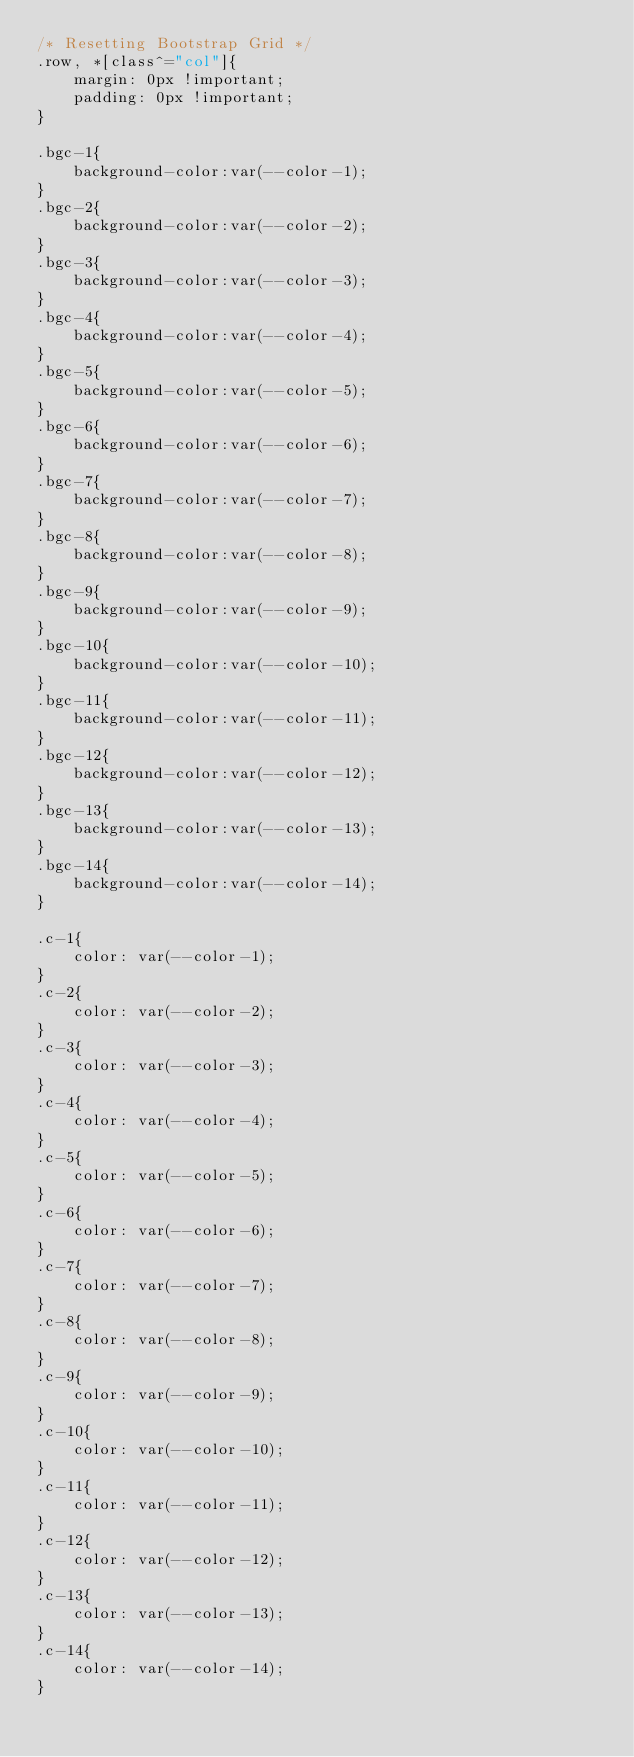<code> <loc_0><loc_0><loc_500><loc_500><_CSS_>/* Resetting Bootstrap Grid */
.row, *[class^="col"]{
    margin: 0px !important;
    padding: 0px !important;
}

.bgc-1{
    background-color:var(--color-1);
}
.bgc-2{
    background-color:var(--color-2);
}
.bgc-3{
    background-color:var(--color-3);
}
.bgc-4{
    background-color:var(--color-4);
}
.bgc-5{
    background-color:var(--color-5);
}
.bgc-6{
    background-color:var(--color-6);
}
.bgc-7{
    background-color:var(--color-7);
}
.bgc-8{
    background-color:var(--color-8);
}
.bgc-9{
    background-color:var(--color-9);
}
.bgc-10{
    background-color:var(--color-10);
}
.bgc-11{
    background-color:var(--color-11);
}
.bgc-12{
    background-color:var(--color-12);
}
.bgc-13{
    background-color:var(--color-13);
}
.bgc-14{
    background-color:var(--color-14);
}

.c-1{
    color: var(--color-1);
}
.c-2{
    color: var(--color-2);
}
.c-3{
    color: var(--color-3);
}
.c-4{
    color: var(--color-4);
}
.c-5{
    color: var(--color-5);
}
.c-6{
    color: var(--color-6);
}
.c-7{
    color: var(--color-7);
}
.c-8{
    color: var(--color-8);
}
.c-9{
    color: var(--color-9);
}
.c-10{
    color: var(--color-10);
}
.c-11{
    color: var(--color-11);
}
.c-12{
    color: var(--color-12);
}
.c-13{
    color: var(--color-13);
}
.c-14{
    color: var(--color-14);
}
</code> 